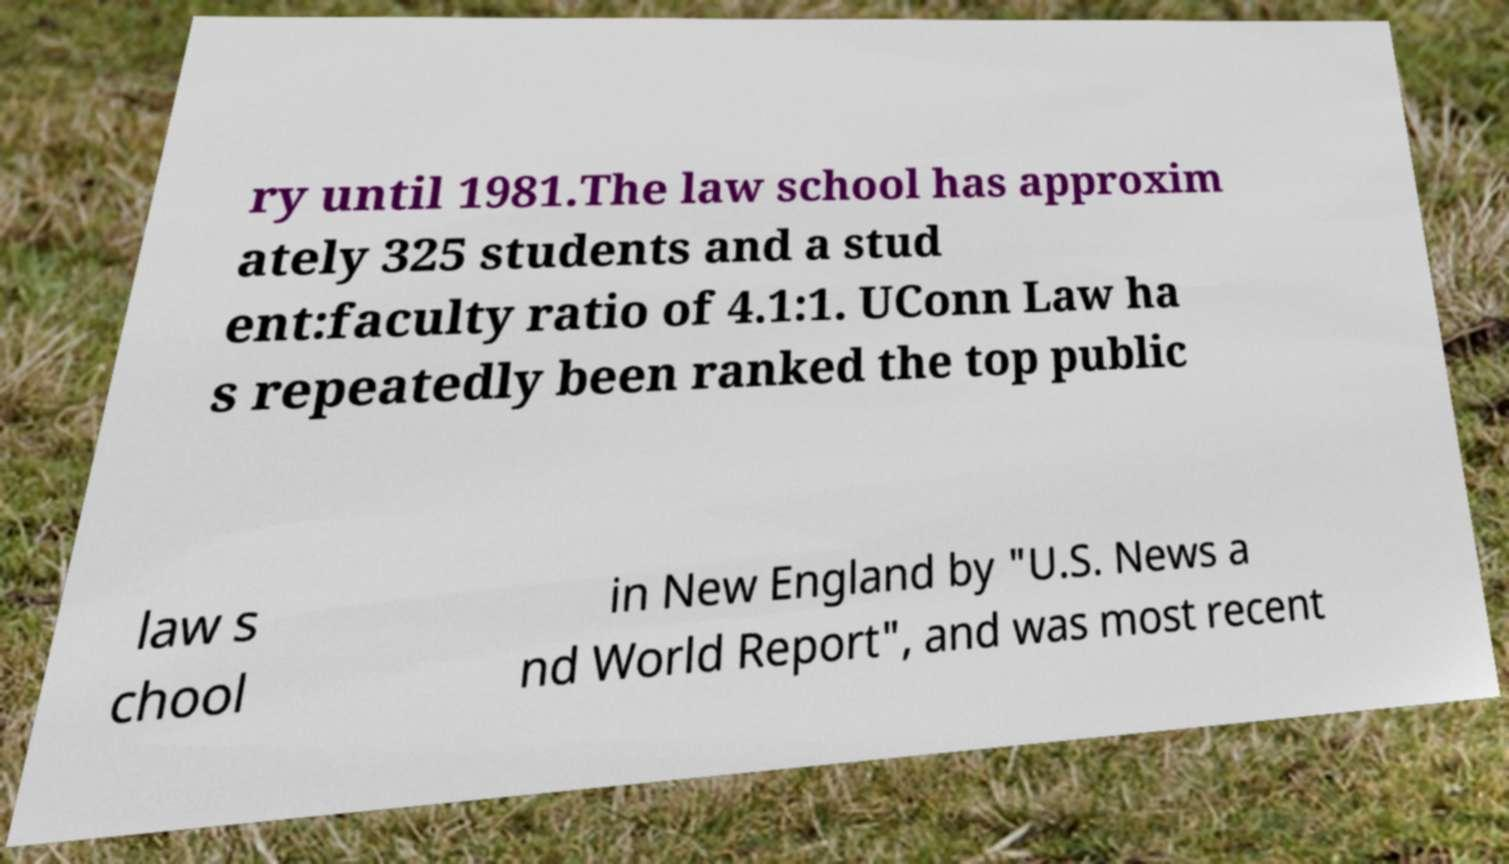What messages or text are displayed in this image? I need them in a readable, typed format. ry until 1981.The law school has approxim ately 325 students and a stud ent:faculty ratio of 4.1:1. UConn Law ha s repeatedly been ranked the top public law s chool in New England by "U.S. News a nd World Report", and was most recent 